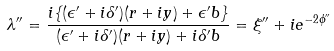<formula> <loc_0><loc_0><loc_500><loc_500>\lambda ^ { \prime \prime } = \frac { i \{ ( \epsilon ^ { \prime } + i \delta ^ { \prime } ) ( r + i y ) + \epsilon ^ { \prime } b \} } { ( \epsilon ^ { \prime } + i \delta ^ { \prime } ) ( r + i y ) + i \delta ^ { \prime } b } = \xi ^ { \prime \prime } + i e ^ { - 2 \phi ^ { \prime \prime } }</formula> 